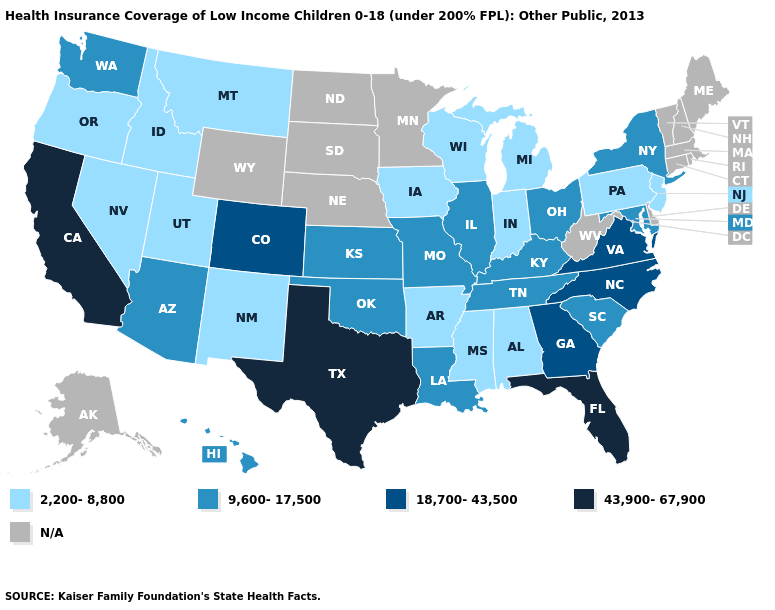Among the states that border New Jersey , which have the highest value?
Answer briefly. New York. Does the first symbol in the legend represent the smallest category?
Quick response, please. Yes. How many symbols are there in the legend?
Quick response, please. 5. Name the states that have a value in the range 2,200-8,800?
Quick response, please. Alabama, Arkansas, Idaho, Indiana, Iowa, Michigan, Mississippi, Montana, Nevada, New Jersey, New Mexico, Oregon, Pennsylvania, Utah, Wisconsin. Name the states that have a value in the range 9,600-17,500?
Quick response, please. Arizona, Hawaii, Illinois, Kansas, Kentucky, Louisiana, Maryland, Missouri, New York, Ohio, Oklahoma, South Carolina, Tennessee, Washington. Name the states that have a value in the range N/A?
Give a very brief answer. Alaska, Connecticut, Delaware, Maine, Massachusetts, Minnesota, Nebraska, New Hampshire, North Dakota, Rhode Island, South Dakota, Vermont, West Virginia, Wyoming. Name the states that have a value in the range 2,200-8,800?
Short answer required. Alabama, Arkansas, Idaho, Indiana, Iowa, Michigan, Mississippi, Montana, Nevada, New Jersey, New Mexico, Oregon, Pennsylvania, Utah, Wisconsin. What is the value of Mississippi?
Answer briefly. 2,200-8,800. Name the states that have a value in the range 18,700-43,500?
Be succinct. Colorado, Georgia, North Carolina, Virginia. Name the states that have a value in the range 2,200-8,800?
Answer briefly. Alabama, Arkansas, Idaho, Indiana, Iowa, Michigan, Mississippi, Montana, Nevada, New Jersey, New Mexico, Oregon, Pennsylvania, Utah, Wisconsin. Which states have the lowest value in the USA?
Answer briefly. Alabama, Arkansas, Idaho, Indiana, Iowa, Michigan, Mississippi, Montana, Nevada, New Jersey, New Mexico, Oregon, Pennsylvania, Utah, Wisconsin. Name the states that have a value in the range 43,900-67,900?
Give a very brief answer. California, Florida, Texas. Does the first symbol in the legend represent the smallest category?
Keep it brief. Yes. Does the first symbol in the legend represent the smallest category?
Write a very short answer. Yes. 